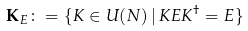Convert formula to latex. <formula><loc_0><loc_0><loc_500><loc_500>\mathbf K _ { E } \colon = \{ K \in U ( N ) \, | \, K E K ^ { \dagger } = E \}</formula> 